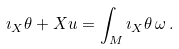Convert formula to latex. <formula><loc_0><loc_0><loc_500><loc_500>\imath _ { X } \theta + X u = \int _ { M } \imath _ { X } \theta \, \omega \, .</formula> 